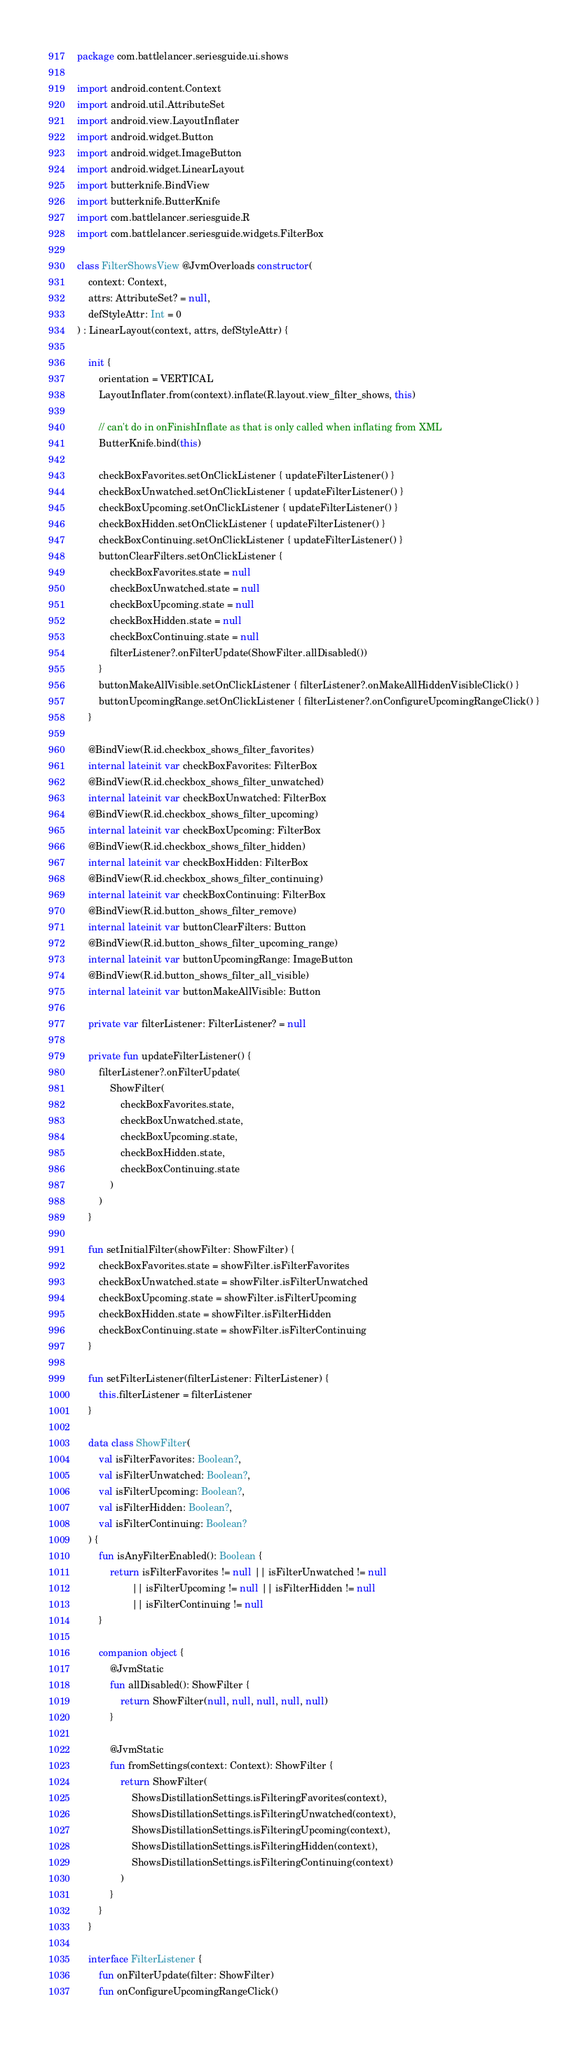Convert code to text. <code><loc_0><loc_0><loc_500><loc_500><_Kotlin_>package com.battlelancer.seriesguide.ui.shows

import android.content.Context
import android.util.AttributeSet
import android.view.LayoutInflater
import android.widget.Button
import android.widget.ImageButton
import android.widget.LinearLayout
import butterknife.BindView
import butterknife.ButterKnife
import com.battlelancer.seriesguide.R
import com.battlelancer.seriesguide.widgets.FilterBox

class FilterShowsView @JvmOverloads constructor(
    context: Context,
    attrs: AttributeSet? = null,
    defStyleAttr: Int = 0
) : LinearLayout(context, attrs, defStyleAttr) {

    init {
        orientation = VERTICAL
        LayoutInflater.from(context).inflate(R.layout.view_filter_shows, this)

        // can't do in onFinishInflate as that is only called when inflating from XML
        ButterKnife.bind(this)

        checkBoxFavorites.setOnClickListener { updateFilterListener() }
        checkBoxUnwatched.setOnClickListener { updateFilterListener() }
        checkBoxUpcoming.setOnClickListener { updateFilterListener() }
        checkBoxHidden.setOnClickListener { updateFilterListener() }
        checkBoxContinuing.setOnClickListener { updateFilterListener() }
        buttonClearFilters.setOnClickListener {
            checkBoxFavorites.state = null
            checkBoxUnwatched.state = null
            checkBoxUpcoming.state = null
            checkBoxHidden.state = null
            checkBoxContinuing.state = null
            filterListener?.onFilterUpdate(ShowFilter.allDisabled())
        }
        buttonMakeAllVisible.setOnClickListener { filterListener?.onMakeAllHiddenVisibleClick() }
        buttonUpcomingRange.setOnClickListener { filterListener?.onConfigureUpcomingRangeClick() }
    }

    @BindView(R.id.checkbox_shows_filter_favorites)
    internal lateinit var checkBoxFavorites: FilterBox
    @BindView(R.id.checkbox_shows_filter_unwatched)
    internal lateinit var checkBoxUnwatched: FilterBox
    @BindView(R.id.checkbox_shows_filter_upcoming)
    internal lateinit var checkBoxUpcoming: FilterBox
    @BindView(R.id.checkbox_shows_filter_hidden)
    internal lateinit var checkBoxHidden: FilterBox
    @BindView(R.id.checkbox_shows_filter_continuing)
    internal lateinit var checkBoxContinuing: FilterBox
    @BindView(R.id.button_shows_filter_remove)
    internal lateinit var buttonClearFilters: Button
    @BindView(R.id.button_shows_filter_upcoming_range)
    internal lateinit var buttonUpcomingRange: ImageButton
    @BindView(R.id.button_shows_filter_all_visible)
    internal lateinit var buttonMakeAllVisible: Button

    private var filterListener: FilterListener? = null

    private fun updateFilterListener() {
        filterListener?.onFilterUpdate(
            ShowFilter(
                checkBoxFavorites.state,
                checkBoxUnwatched.state,
                checkBoxUpcoming.state,
                checkBoxHidden.state,
                checkBoxContinuing.state
            )
        )
    }

    fun setInitialFilter(showFilter: ShowFilter) {
        checkBoxFavorites.state = showFilter.isFilterFavorites
        checkBoxUnwatched.state = showFilter.isFilterUnwatched
        checkBoxUpcoming.state = showFilter.isFilterUpcoming
        checkBoxHidden.state = showFilter.isFilterHidden
        checkBoxContinuing.state = showFilter.isFilterContinuing
    }

    fun setFilterListener(filterListener: FilterListener) {
        this.filterListener = filterListener
    }

    data class ShowFilter(
        val isFilterFavorites: Boolean?,
        val isFilterUnwatched: Boolean?,
        val isFilterUpcoming: Boolean?,
        val isFilterHidden: Boolean?,
        val isFilterContinuing: Boolean?
    ) {
        fun isAnyFilterEnabled(): Boolean {
            return isFilterFavorites != null || isFilterUnwatched != null
                    || isFilterUpcoming != null || isFilterHidden != null
                    || isFilterContinuing != null
        }

        companion object {
            @JvmStatic
            fun allDisabled(): ShowFilter {
                return ShowFilter(null, null, null, null, null)
            }

            @JvmStatic
            fun fromSettings(context: Context): ShowFilter {
                return ShowFilter(
                    ShowsDistillationSettings.isFilteringFavorites(context),
                    ShowsDistillationSettings.isFilteringUnwatched(context),
                    ShowsDistillationSettings.isFilteringUpcoming(context),
                    ShowsDistillationSettings.isFilteringHidden(context),
                    ShowsDistillationSettings.isFilteringContinuing(context)
                )
            }
        }
    }

    interface FilterListener {
        fun onFilterUpdate(filter: ShowFilter)
        fun onConfigureUpcomingRangeClick()</code> 